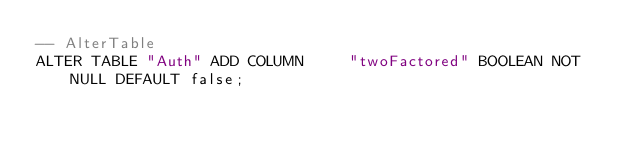Convert code to text. <code><loc_0><loc_0><loc_500><loc_500><_SQL_>-- AlterTable
ALTER TABLE "Auth" ADD COLUMN     "twoFactored" BOOLEAN NOT NULL DEFAULT false;
</code> 